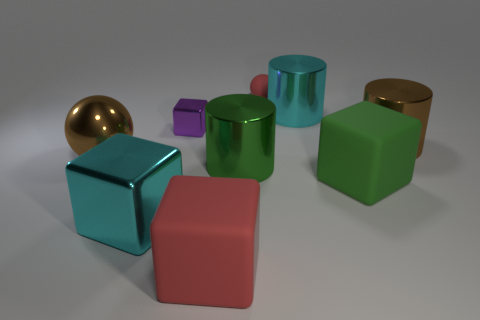What number of other objects are there of the same color as the big metallic block?
Your answer should be very brief. 1. What is the shape of the tiny red matte thing?
Offer a terse response. Sphere. What is the size of the shiny cube that is behind the shiny cylinder in front of the brown sphere?
Ensure brevity in your answer.  Small. What number of objects are either small rubber balls or big green matte objects?
Your answer should be very brief. 2. Is the small purple thing the same shape as the big green rubber thing?
Your answer should be compact. Yes. Is there a big purple cube made of the same material as the small cube?
Ensure brevity in your answer.  No. Are there any large objects behind the green metallic object that is in front of the tiny purple shiny block?
Your answer should be very brief. Yes. There is a red matte object that is in front of the brown metal ball; does it have the same size as the green block?
Ensure brevity in your answer.  Yes. How big is the green metallic object?
Provide a short and direct response. Large. Is there a big shiny thing that has the same color as the large metal ball?
Make the answer very short. Yes. 